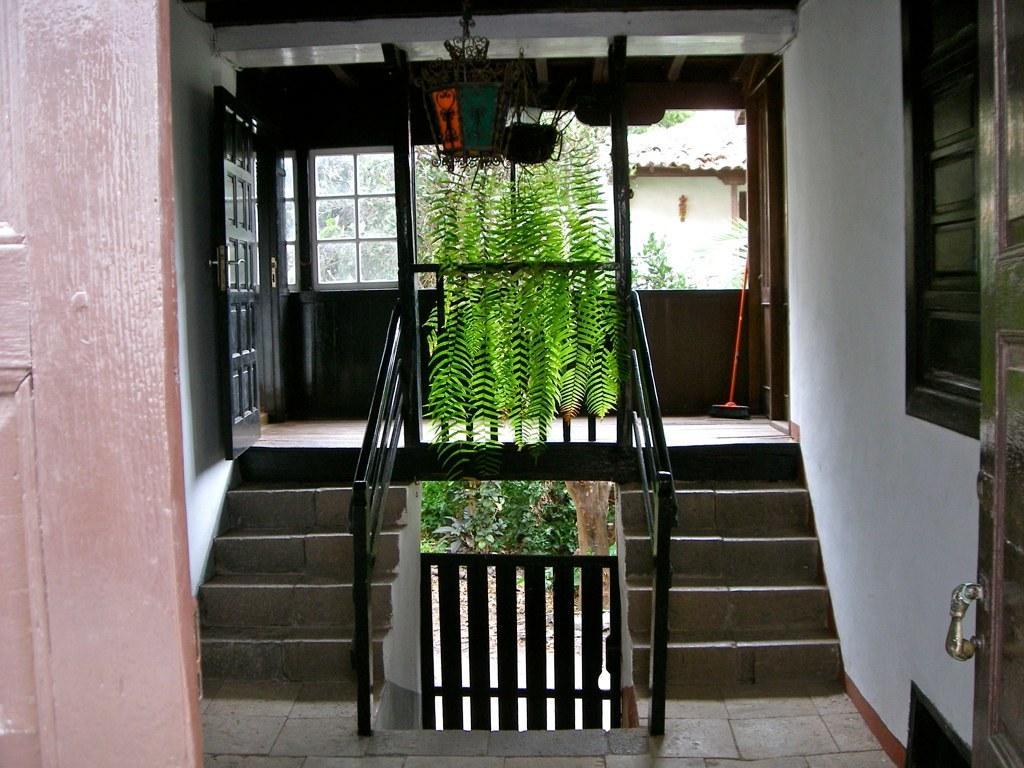Please provide a concise description of this image. In this image I can see the doors. I can see the plants. On the left and right side, I can see the stairs. In the background, I can see a house. 